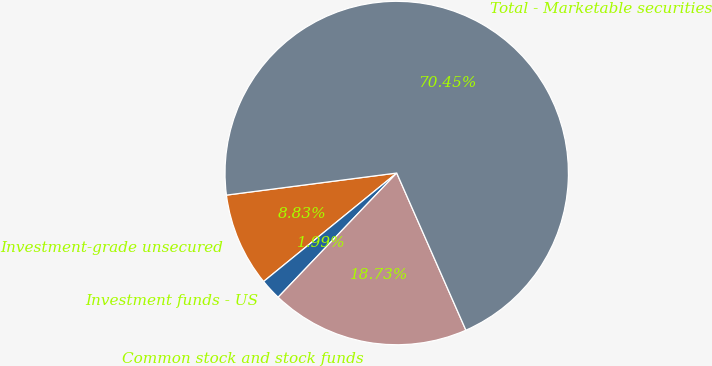Convert chart. <chart><loc_0><loc_0><loc_500><loc_500><pie_chart><fcel>Investment-grade unsecured<fcel>Investment funds - US<fcel>Common stock and stock funds<fcel>Total - Marketable securities<nl><fcel>8.83%<fcel>1.99%<fcel>18.73%<fcel>70.45%<nl></chart> 